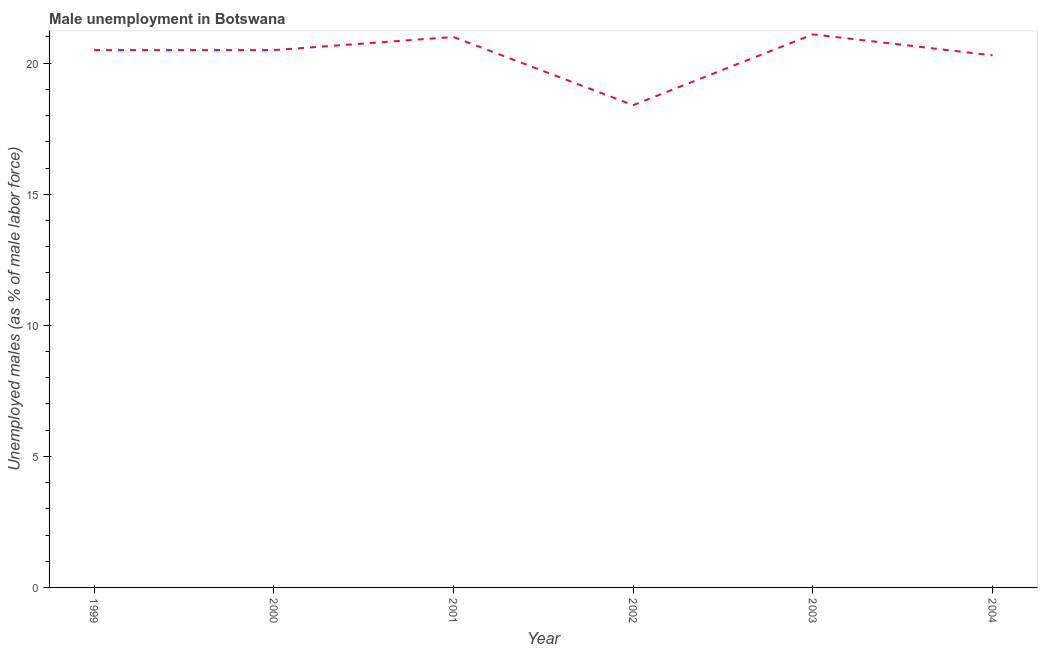What is the unemployed males population in 2004?
Give a very brief answer. 20.3. Across all years, what is the maximum unemployed males population?
Ensure brevity in your answer.  21.1. Across all years, what is the minimum unemployed males population?
Make the answer very short. 18.4. In which year was the unemployed males population maximum?
Your response must be concise. 2003. In which year was the unemployed males population minimum?
Provide a short and direct response. 2002. What is the sum of the unemployed males population?
Your answer should be compact. 121.8. What is the difference between the unemployed males population in 2000 and 2002?
Keep it short and to the point. 2.1. What is the average unemployed males population per year?
Offer a terse response. 20.3. What is the ratio of the unemployed males population in 2001 to that in 2003?
Ensure brevity in your answer.  1. Is the difference between the unemployed males population in 2003 and 2004 greater than the difference between any two years?
Your answer should be very brief. No. What is the difference between the highest and the second highest unemployed males population?
Your answer should be very brief. 0.1. What is the difference between the highest and the lowest unemployed males population?
Keep it short and to the point. 2.7. What is the title of the graph?
Keep it short and to the point. Male unemployment in Botswana. What is the label or title of the X-axis?
Your response must be concise. Year. What is the label or title of the Y-axis?
Your answer should be very brief. Unemployed males (as % of male labor force). What is the Unemployed males (as % of male labor force) of 2000?
Provide a succinct answer. 20.5. What is the Unemployed males (as % of male labor force) in 2001?
Offer a terse response. 21. What is the Unemployed males (as % of male labor force) of 2002?
Make the answer very short. 18.4. What is the Unemployed males (as % of male labor force) in 2003?
Keep it short and to the point. 21.1. What is the Unemployed males (as % of male labor force) in 2004?
Your answer should be compact. 20.3. What is the difference between the Unemployed males (as % of male labor force) in 1999 and 2000?
Offer a very short reply. 0. What is the difference between the Unemployed males (as % of male labor force) in 1999 and 2001?
Ensure brevity in your answer.  -0.5. What is the difference between the Unemployed males (as % of male labor force) in 1999 and 2002?
Make the answer very short. 2.1. What is the difference between the Unemployed males (as % of male labor force) in 1999 and 2003?
Keep it short and to the point. -0.6. What is the difference between the Unemployed males (as % of male labor force) in 1999 and 2004?
Provide a short and direct response. 0.2. What is the difference between the Unemployed males (as % of male labor force) in 2000 and 2001?
Provide a short and direct response. -0.5. What is the difference between the Unemployed males (as % of male labor force) in 2000 and 2003?
Offer a terse response. -0.6. What is the difference between the Unemployed males (as % of male labor force) in 2000 and 2004?
Provide a succinct answer. 0.2. What is the difference between the Unemployed males (as % of male labor force) in 2001 and 2003?
Keep it short and to the point. -0.1. What is the difference between the Unemployed males (as % of male labor force) in 2001 and 2004?
Give a very brief answer. 0.7. What is the difference between the Unemployed males (as % of male labor force) in 2002 and 2003?
Offer a terse response. -2.7. What is the difference between the Unemployed males (as % of male labor force) in 2003 and 2004?
Ensure brevity in your answer.  0.8. What is the ratio of the Unemployed males (as % of male labor force) in 1999 to that in 2000?
Your response must be concise. 1. What is the ratio of the Unemployed males (as % of male labor force) in 1999 to that in 2001?
Provide a short and direct response. 0.98. What is the ratio of the Unemployed males (as % of male labor force) in 1999 to that in 2002?
Offer a terse response. 1.11. What is the ratio of the Unemployed males (as % of male labor force) in 2000 to that in 2002?
Ensure brevity in your answer.  1.11. What is the ratio of the Unemployed males (as % of male labor force) in 2000 to that in 2003?
Give a very brief answer. 0.97. What is the ratio of the Unemployed males (as % of male labor force) in 2000 to that in 2004?
Give a very brief answer. 1.01. What is the ratio of the Unemployed males (as % of male labor force) in 2001 to that in 2002?
Offer a terse response. 1.14. What is the ratio of the Unemployed males (as % of male labor force) in 2001 to that in 2004?
Make the answer very short. 1.03. What is the ratio of the Unemployed males (as % of male labor force) in 2002 to that in 2003?
Offer a very short reply. 0.87. What is the ratio of the Unemployed males (as % of male labor force) in 2002 to that in 2004?
Make the answer very short. 0.91. What is the ratio of the Unemployed males (as % of male labor force) in 2003 to that in 2004?
Ensure brevity in your answer.  1.04. 